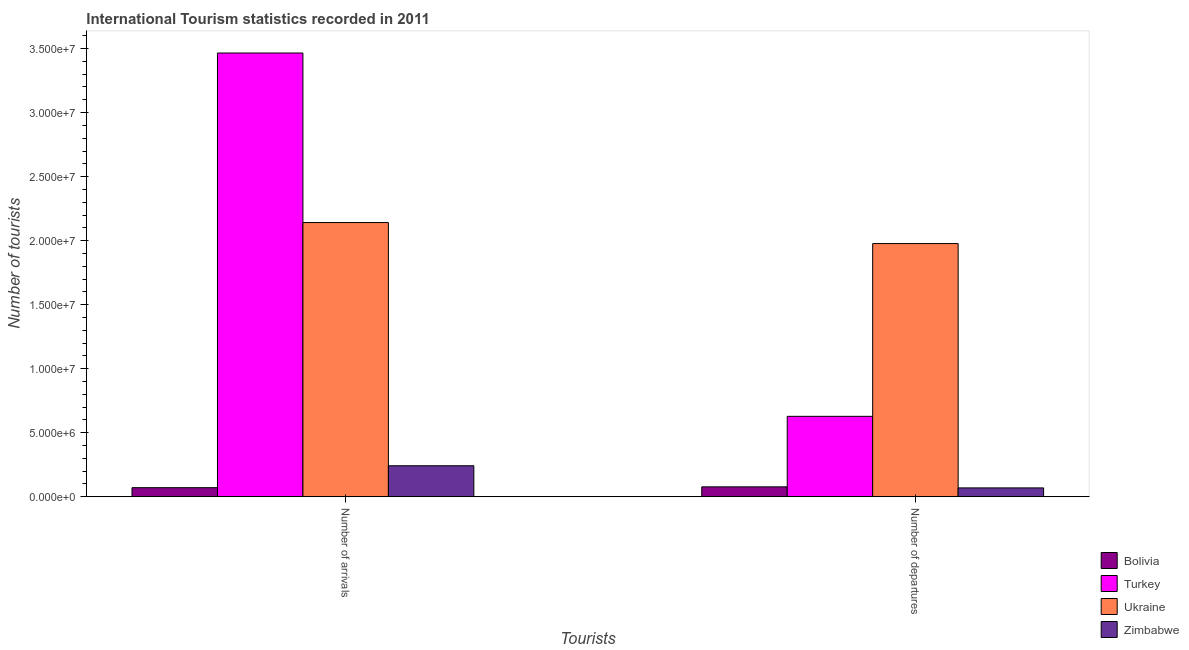How many different coloured bars are there?
Provide a succinct answer. 4. Are the number of bars per tick equal to the number of legend labels?
Provide a short and direct response. Yes. How many bars are there on the 2nd tick from the left?
Provide a short and direct response. 4. How many bars are there on the 1st tick from the right?
Make the answer very short. 4. What is the label of the 1st group of bars from the left?
Provide a short and direct response. Number of arrivals. What is the number of tourist departures in Bolivia?
Ensure brevity in your answer.  7.75e+05. Across all countries, what is the maximum number of tourist departures?
Make the answer very short. 1.98e+07. Across all countries, what is the minimum number of tourist arrivals?
Your answer should be very brief. 7.11e+05. In which country was the number of tourist arrivals maximum?
Keep it short and to the point. Turkey. What is the total number of tourist departures in the graph?
Offer a very short reply. 2.75e+07. What is the difference between the number of tourist arrivals in Turkey and that in Zimbabwe?
Make the answer very short. 3.22e+07. What is the difference between the number of tourist departures in Turkey and the number of tourist arrivals in Bolivia?
Your answer should be very brief. 5.57e+06. What is the average number of tourist arrivals per country?
Offer a terse response. 1.48e+07. What is the difference between the number of tourist departures and number of tourist arrivals in Turkey?
Your answer should be very brief. -2.84e+07. What is the ratio of the number of tourist departures in Turkey to that in Ukraine?
Your answer should be compact. 0.32. In how many countries, is the number of tourist arrivals greater than the average number of tourist arrivals taken over all countries?
Your answer should be very brief. 2. What does the 3rd bar from the left in Number of arrivals represents?
Ensure brevity in your answer.  Ukraine. What does the 2nd bar from the right in Number of departures represents?
Provide a succinct answer. Ukraine. What is the difference between two consecutive major ticks on the Y-axis?
Offer a terse response. 5.00e+06. Are the values on the major ticks of Y-axis written in scientific E-notation?
Offer a very short reply. Yes. Does the graph contain grids?
Your answer should be very brief. No. What is the title of the graph?
Your response must be concise. International Tourism statistics recorded in 2011. Does "Norway" appear as one of the legend labels in the graph?
Provide a succinct answer. No. What is the label or title of the X-axis?
Ensure brevity in your answer.  Tourists. What is the label or title of the Y-axis?
Give a very brief answer. Number of tourists. What is the Number of tourists in Bolivia in Number of arrivals?
Your answer should be very brief. 7.11e+05. What is the Number of tourists in Turkey in Number of arrivals?
Keep it short and to the point. 3.47e+07. What is the Number of tourists in Ukraine in Number of arrivals?
Offer a terse response. 2.14e+07. What is the Number of tourists in Zimbabwe in Number of arrivals?
Give a very brief answer. 2.42e+06. What is the Number of tourists in Bolivia in Number of departures?
Your answer should be very brief. 7.75e+05. What is the Number of tourists in Turkey in Number of departures?
Offer a very short reply. 6.28e+06. What is the Number of tourists in Ukraine in Number of departures?
Ensure brevity in your answer.  1.98e+07. What is the Number of tourists in Zimbabwe in Number of departures?
Give a very brief answer. 6.93e+05. Across all Tourists, what is the maximum Number of tourists in Bolivia?
Offer a very short reply. 7.75e+05. Across all Tourists, what is the maximum Number of tourists in Turkey?
Provide a succinct answer. 3.47e+07. Across all Tourists, what is the maximum Number of tourists of Ukraine?
Offer a very short reply. 2.14e+07. Across all Tourists, what is the maximum Number of tourists in Zimbabwe?
Your answer should be very brief. 2.42e+06. Across all Tourists, what is the minimum Number of tourists of Bolivia?
Ensure brevity in your answer.  7.11e+05. Across all Tourists, what is the minimum Number of tourists of Turkey?
Ensure brevity in your answer.  6.28e+06. Across all Tourists, what is the minimum Number of tourists of Ukraine?
Make the answer very short. 1.98e+07. Across all Tourists, what is the minimum Number of tourists in Zimbabwe?
Your answer should be very brief. 6.93e+05. What is the total Number of tourists in Bolivia in the graph?
Offer a terse response. 1.49e+06. What is the total Number of tourists in Turkey in the graph?
Your answer should be very brief. 4.09e+07. What is the total Number of tourists in Ukraine in the graph?
Provide a short and direct response. 4.12e+07. What is the total Number of tourists in Zimbabwe in the graph?
Give a very brief answer. 3.12e+06. What is the difference between the Number of tourists in Bolivia in Number of arrivals and that in Number of departures?
Your response must be concise. -6.40e+04. What is the difference between the Number of tourists in Turkey in Number of arrivals and that in Number of departures?
Ensure brevity in your answer.  2.84e+07. What is the difference between the Number of tourists in Ukraine in Number of arrivals and that in Number of departures?
Your answer should be compact. 1.64e+06. What is the difference between the Number of tourists in Zimbabwe in Number of arrivals and that in Number of departures?
Keep it short and to the point. 1.73e+06. What is the difference between the Number of tourists of Bolivia in Number of arrivals and the Number of tourists of Turkey in Number of departures?
Provide a short and direct response. -5.57e+06. What is the difference between the Number of tourists of Bolivia in Number of arrivals and the Number of tourists of Ukraine in Number of departures?
Make the answer very short. -1.91e+07. What is the difference between the Number of tourists in Bolivia in Number of arrivals and the Number of tourists in Zimbabwe in Number of departures?
Your answer should be compact. 1.80e+04. What is the difference between the Number of tourists in Turkey in Number of arrivals and the Number of tourists in Ukraine in Number of departures?
Provide a short and direct response. 1.49e+07. What is the difference between the Number of tourists of Turkey in Number of arrivals and the Number of tourists of Zimbabwe in Number of departures?
Your response must be concise. 3.40e+07. What is the difference between the Number of tourists of Ukraine in Number of arrivals and the Number of tourists of Zimbabwe in Number of departures?
Ensure brevity in your answer.  2.07e+07. What is the average Number of tourists in Bolivia per Tourists?
Keep it short and to the point. 7.43e+05. What is the average Number of tourists of Turkey per Tourists?
Your answer should be compact. 2.05e+07. What is the average Number of tourists of Ukraine per Tourists?
Offer a very short reply. 2.06e+07. What is the average Number of tourists in Zimbabwe per Tourists?
Make the answer very short. 1.56e+06. What is the difference between the Number of tourists of Bolivia and Number of tourists of Turkey in Number of arrivals?
Make the answer very short. -3.39e+07. What is the difference between the Number of tourists in Bolivia and Number of tourists in Ukraine in Number of arrivals?
Keep it short and to the point. -2.07e+07. What is the difference between the Number of tourists in Bolivia and Number of tourists in Zimbabwe in Number of arrivals?
Make the answer very short. -1.71e+06. What is the difference between the Number of tourists in Turkey and Number of tourists in Ukraine in Number of arrivals?
Make the answer very short. 1.32e+07. What is the difference between the Number of tourists in Turkey and Number of tourists in Zimbabwe in Number of arrivals?
Offer a very short reply. 3.22e+07. What is the difference between the Number of tourists in Ukraine and Number of tourists in Zimbabwe in Number of arrivals?
Provide a succinct answer. 1.90e+07. What is the difference between the Number of tourists in Bolivia and Number of tourists in Turkey in Number of departures?
Offer a terse response. -5.51e+06. What is the difference between the Number of tourists in Bolivia and Number of tourists in Ukraine in Number of departures?
Ensure brevity in your answer.  -1.90e+07. What is the difference between the Number of tourists of Bolivia and Number of tourists of Zimbabwe in Number of departures?
Give a very brief answer. 8.20e+04. What is the difference between the Number of tourists of Turkey and Number of tourists of Ukraine in Number of departures?
Your answer should be very brief. -1.35e+07. What is the difference between the Number of tourists of Turkey and Number of tourists of Zimbabwe in Number of departures?
Offer a terse response. 5.59e+06. What is the difference between the Number of tourists in Ukraine and Number of tourists in Zimbabwe in Number of departures?
Your answer should be compact. 1.91e+07. What is the ratio of the Number of tourists of Bolivia in Number of arrivals to that in Number of departures?
Offer a very short reply. 0.92. What is the ratio of the Number of tourists in Turkey in Number of arrivals to that in Number of departures?
Offer a terse response. 5.52. What is the ratio of the Number of tourists in Ukraine in Number of arrivals to that in Number of departures?
Give a very brief answer. 1.08. What is the ratio of the Number of tourists of Zimbabwe in Number of arrivals to that in Number of departures?
Offer a very short reply. 3.5. What is the difference between the highest and the second highest Number of tourists in Bolivia?
Your answer should be compact. 6.40e+04. What is the difference between the highest and the second highest Number of tourists of Turkey?
Ensure brevity in your answer.  2.84e+07. What is the difference between the highest and the second highest Number of tourists in Ukraine?
Provide a short and direct response. 1.64e+06. What is the difference between the highest and the second highest Number of tourists in Zimbabwe?
Offer a terse response. 1.73e+06. What is the difference between the highest and the lowest Number of tourists of Bolivia?
Provide a short and direct response. 6.40e+04. What is the difference between the highest and the lowest Number of tourists in Turkey?
Give a very brief answer. 2.84e+07. What is the difference between the highest and the lowest Number of tourists of Ukraine?
Offer a very short reply. 1.64e+06. What is the difference between the highest and the lowest Number of tourists of Zimbabwe?
Your answer should be very brief. 1.73e+06. 